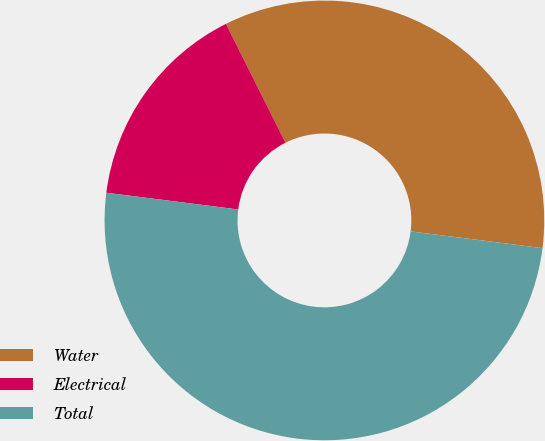<chart> <loc_0><loc_0><loc_500><loc_500><pie_chart><fcel>Water<fcel>Electrical<fcel>Total<nl><fcel>34.4%<fcel>15.6%<fcel>50.0%<nl></chart> 